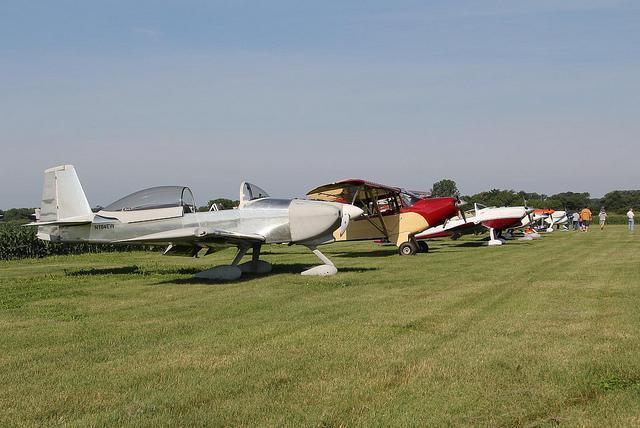How many airplanes can be seen?
Give a very brief answer. 3. 